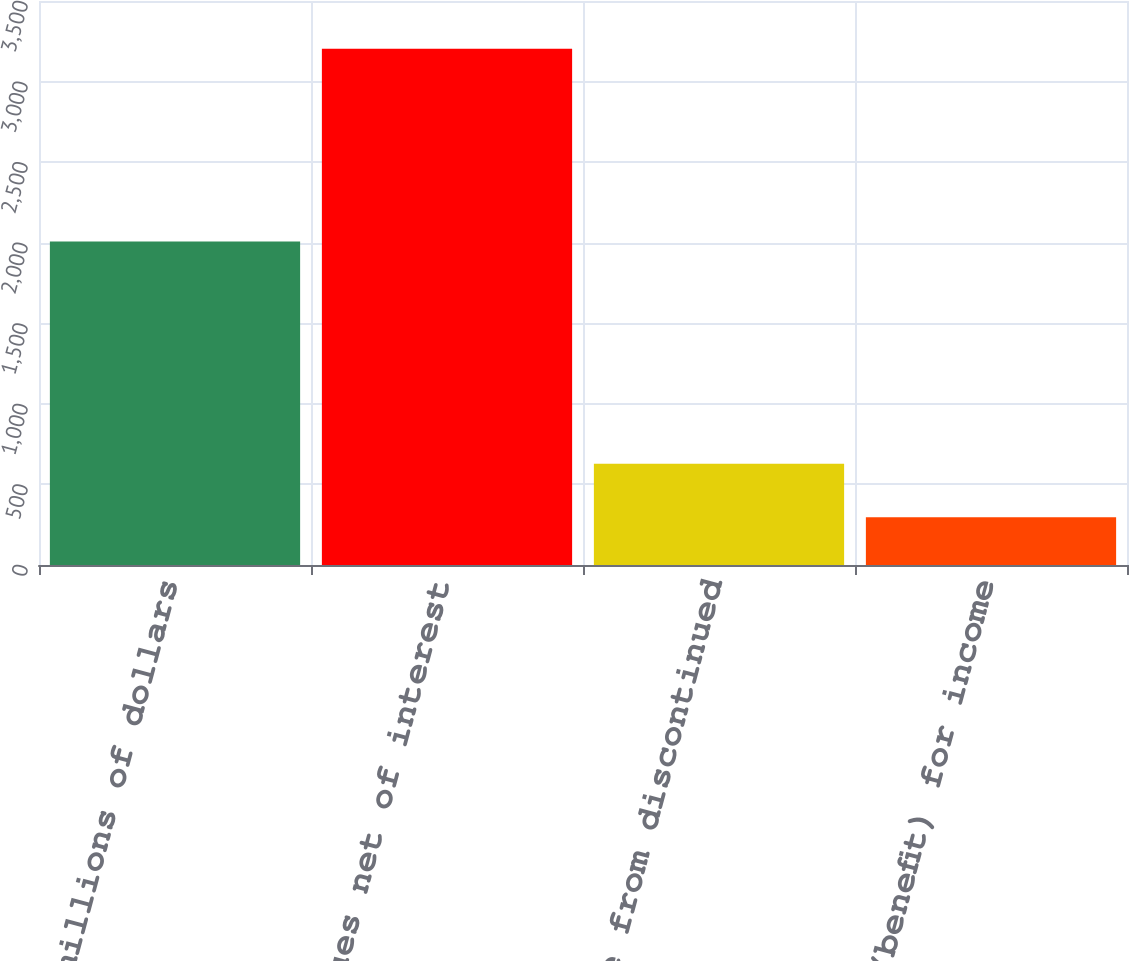<chart> <loc_0><loc_0><loc_500><loc_500><bar_chart><fcel>In millions of dollars<fcel>Total revenues net of interest<fcel>Income from discontinued<fcel>Provision (benefit) for income<nl><fcel>2007<fcel>3203<fcel>628<fcel>297<nl></chart> 